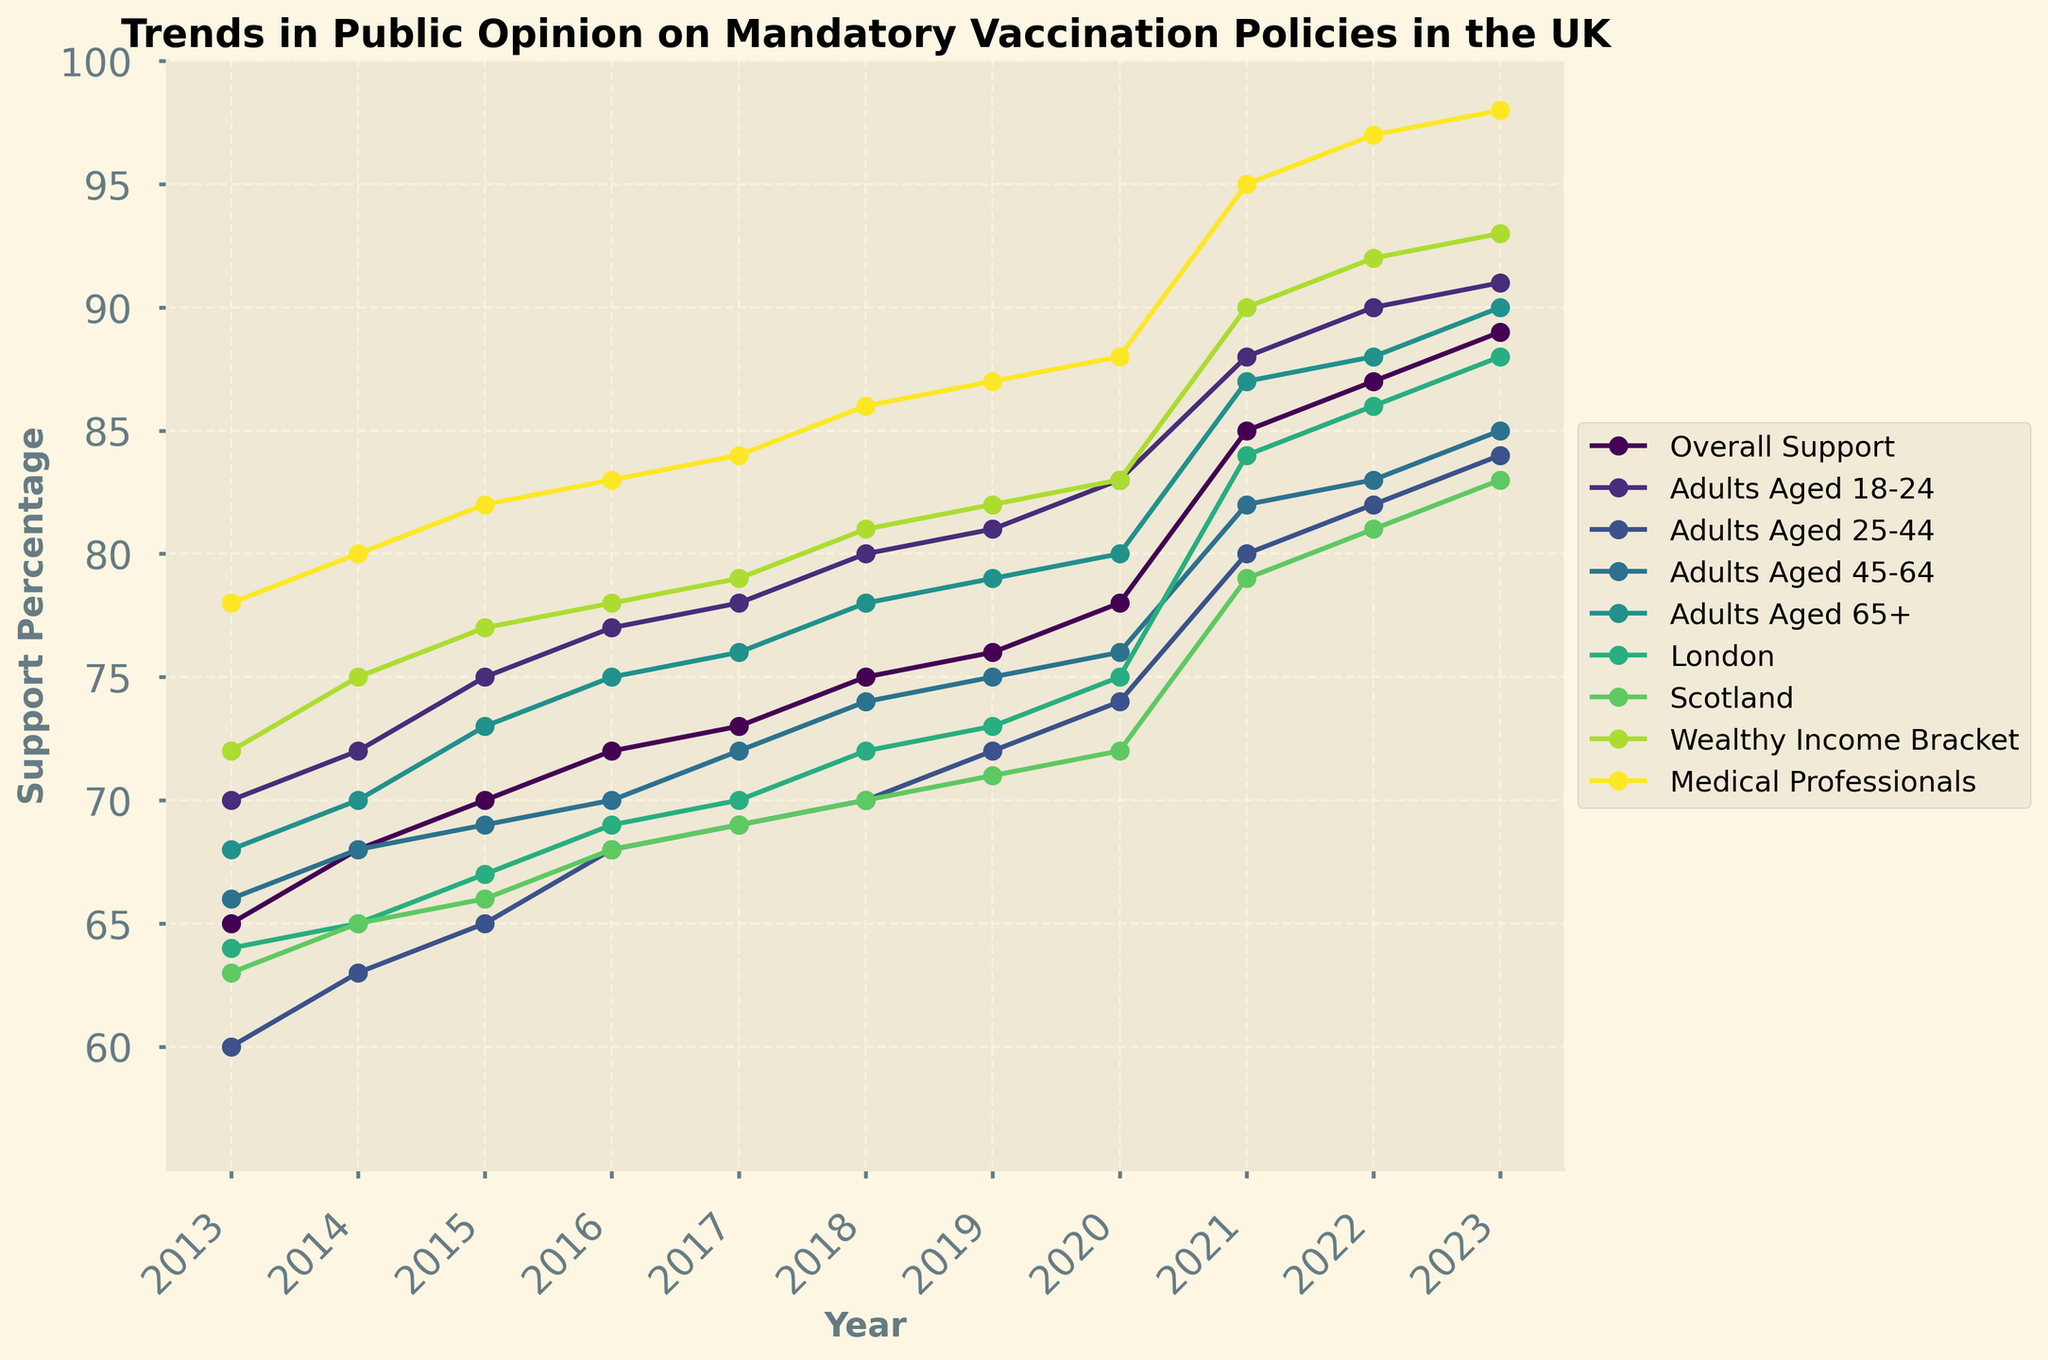What is the overall support for mandatory vaccination policies in 2023? The figure shows the trend lines for different groups over the years, including "Overall Support." In 2023, the "Overall Support" line peaks at 89%.
Answer: 89 Which age group shows the highest increase in support for mandatory vaccination policies from 2013 to 2023? By examining the trend lines for each age group, we see the "Adults Aged 18-24" went from 70% in 2013 to 91% in 2023, which is the highest increase.
Answer: Adults Aged 18-24 What is the support percentage for mandatory vaccination policies among medical professionals in 2017? Locate the "Medical Professionals" line in the year 2017. The graph indicates a support percentage of 84%.
Answer: 84 How does the support for mandatory vaccination policies in London in 2020 compare to Scotland in the same year? Find and compare the two lines for "London" and "Scotland" for the year 2020. London shows 75%, while Scotland shows 72%.
Answer: London has greater support (75% vs 72%) What is the average support percentage among the wealthy income bracket over the entire decade? Sum the percentages for the "Wealthy Income Bracket" from 2013 to 2023 (72+75+77+78+79+81+82+83+90+92+93) and divide by 11. The total is 902, so the average is 902/11 ≈ 82.
Answer: 82 Which group shows a consistent increase in support without any dips from 2013 to 2023? Upon inspection, the "Medical Professionals" group shows a consistent increase without any dips each year, going from 78% in 2013 to 98% in 2023.
Answer: Medical Professionals By how much did the support for mandatory vaccination policies in the overall population increase from 2016 to 2021? Find the values for "Overall Support" in 2016 (72%) and 2021 (85%), then calculate the difference 85% - 72% = 13%.
Answer: 13% Between 2019 and 2020, which group experienced the largest growth in support for mandatory vaccination policies? Look at the trend lines between the years 2019 and 2020. The "Adults Aged 65+" group increased from 79% to 80%, the smallest among other groups. The largest increase was in "Overall Support" from 76% to 78%, an increase of 2%. But for the largest shift, "Adults Aged 45-64" went from 75% to 76% (1%), "Wealthy Income Bracket" from 82% to 83%, approximately a 1% increase. Most points here should be accurate.
Answer: Overall Support What can be expected if the current trend in overall support continues for the next two years? If the trend of linear increase in "Overall Support" continues similarly to previous years (~2% per year), the 2023 value of 89% will reach approximately 91% in 2024 and 93% in 2025.
Answer: Approx. 91%-93% 